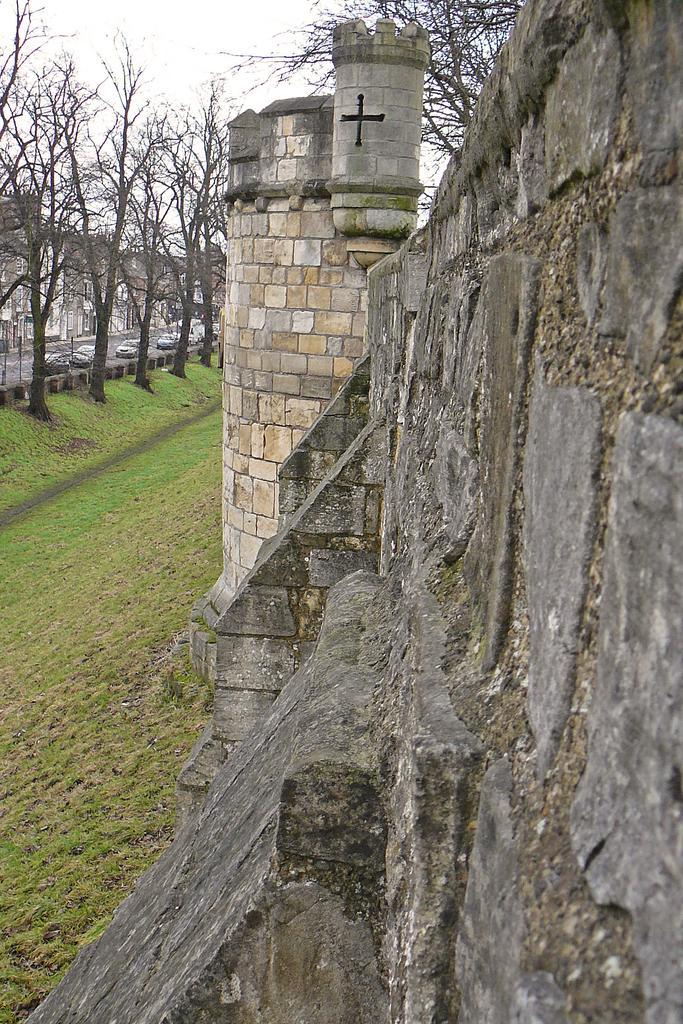Please provide a concise description of this image. We can see there is a wall on the right side of this image, and there are some trees in the background. There are some cars on the road is on the left side of this image and there is a grassy land at the bottom of this image. 